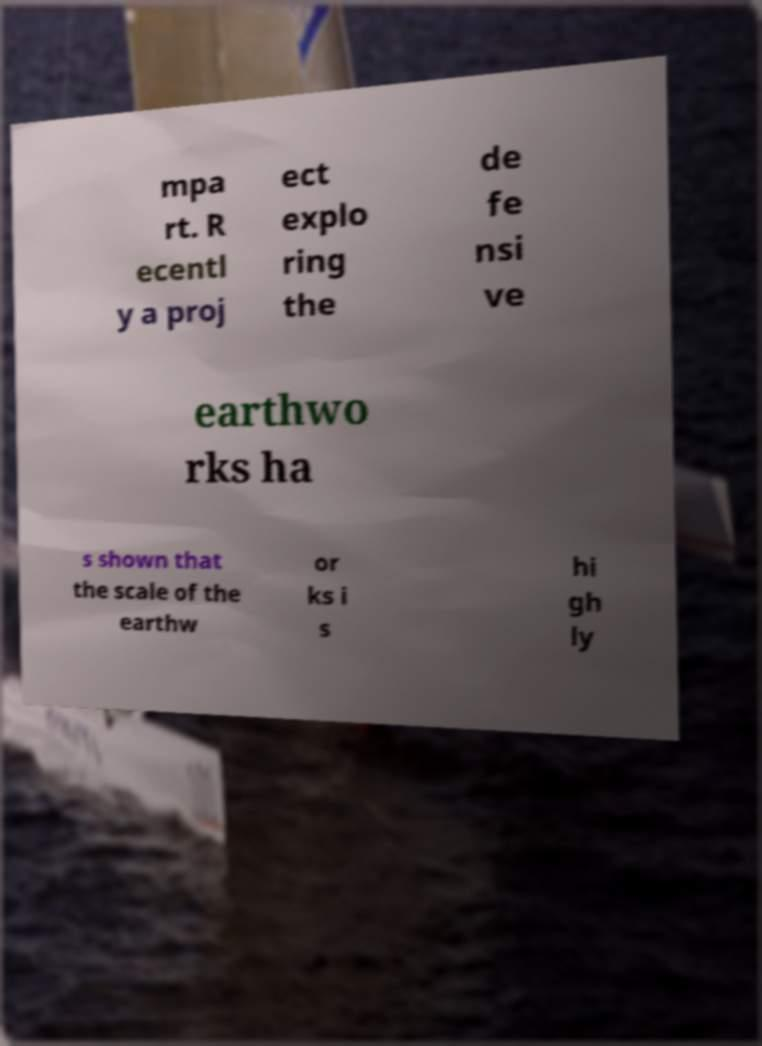For documentation purposes, I need the text within this image transcribed. Could you provide that? mpa rt. R ecentl y a proj ect explo ring the de fe nsi ve earthwo rks ha s shown that the scale of the earthw or ks i s hi gh ly 